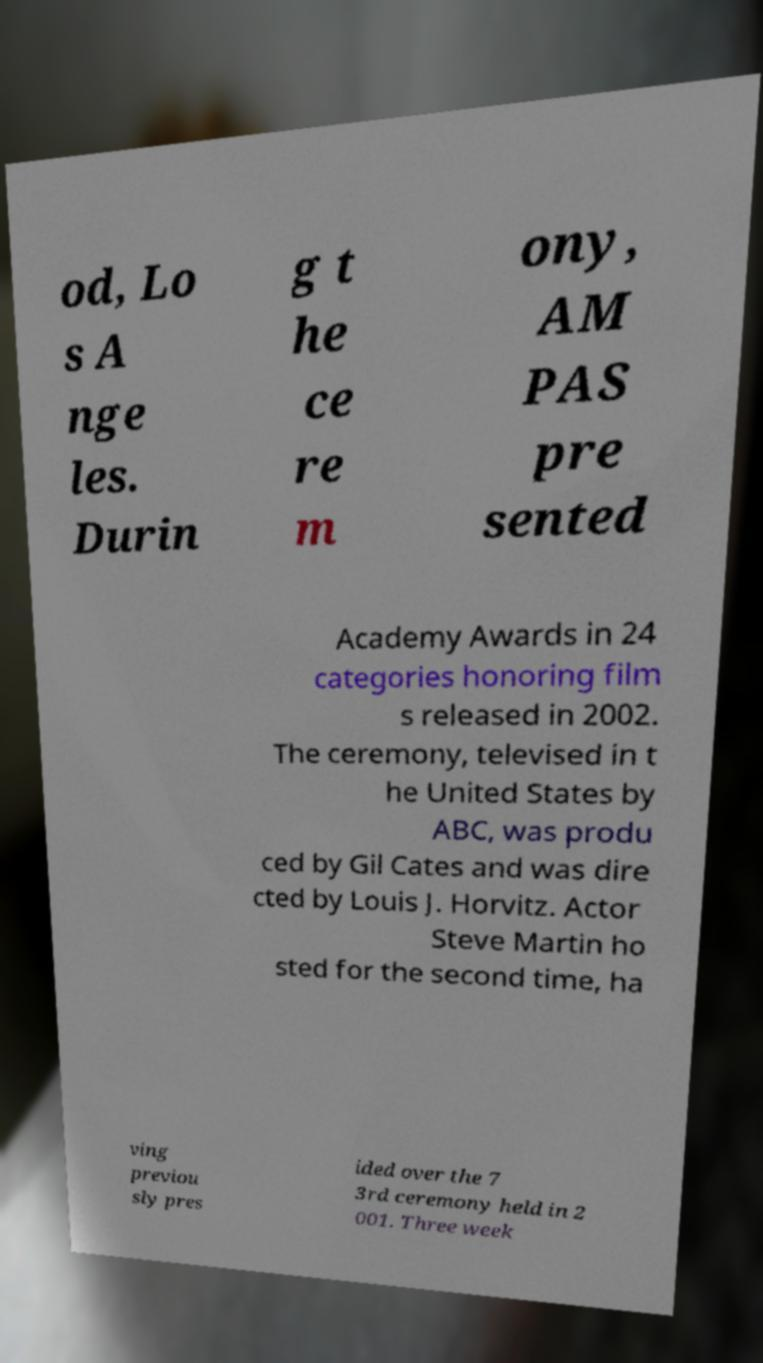Please identify and transcribe the text found in this image. od, Lo s A nge les. Durin g t he ce re m ony, AM PAS pre sented Academy Awards in 24 categories honoring film s released in 2002. The ceremony, televised in t he United States by ABC, was produ ced by Gil Cates and was dire cted by Louis J. Horvitz. Actor Steve Martin ho sted for the second time, ha ving previou sly pres ided over the 7 3rd ceremony held in 2 001. Three week 